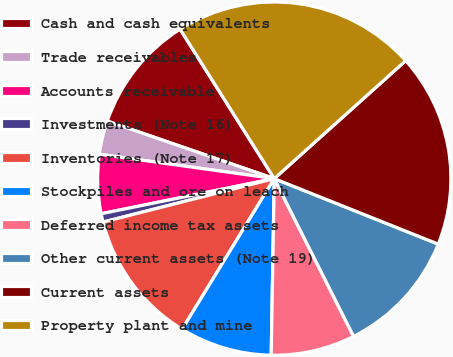Convert chart to OTSL. <chart><loc_0><loc_0><loc_500><loc_500><pie_chart><fcel>Cash and cash equivalents<fcel>Trade receivables<fcel>Accounts receivable<fcel>Investments (Note 16)<fcel>Inventories (Note 17)<fcel>Stockpiles and ore on leach<fcel>Deferred income tax assets<fcel>Other current assets (Note 19)<fcel>Current assets<fcel>Property plant and mine<nl><fcel>10.77%<fcel>3.08%<fcel>5.39%<fcel>0.77%<fcel>12.31%<fcel>8.46%<fcel>7.69%<fcel>11.54%<fcel>17.69%<fcel>22.31%<nl></chart> 